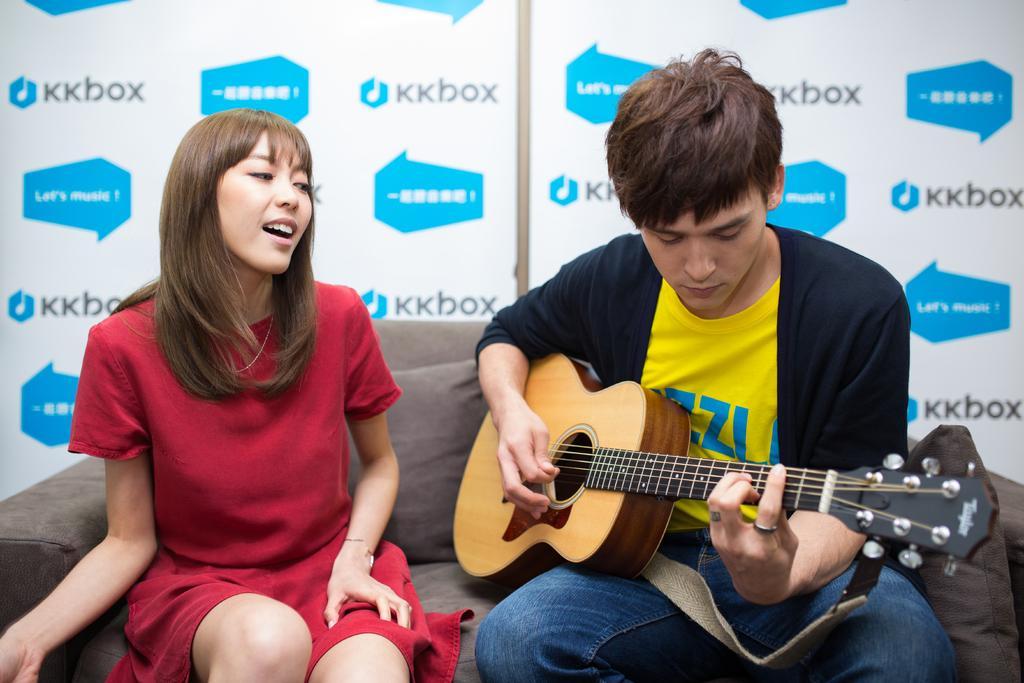Can you describe this image briefly? In this image there is a woman with red color shirt sitting in the couch, another man sitting in couch and playing guitar and in the back ground there is a hoarding. 